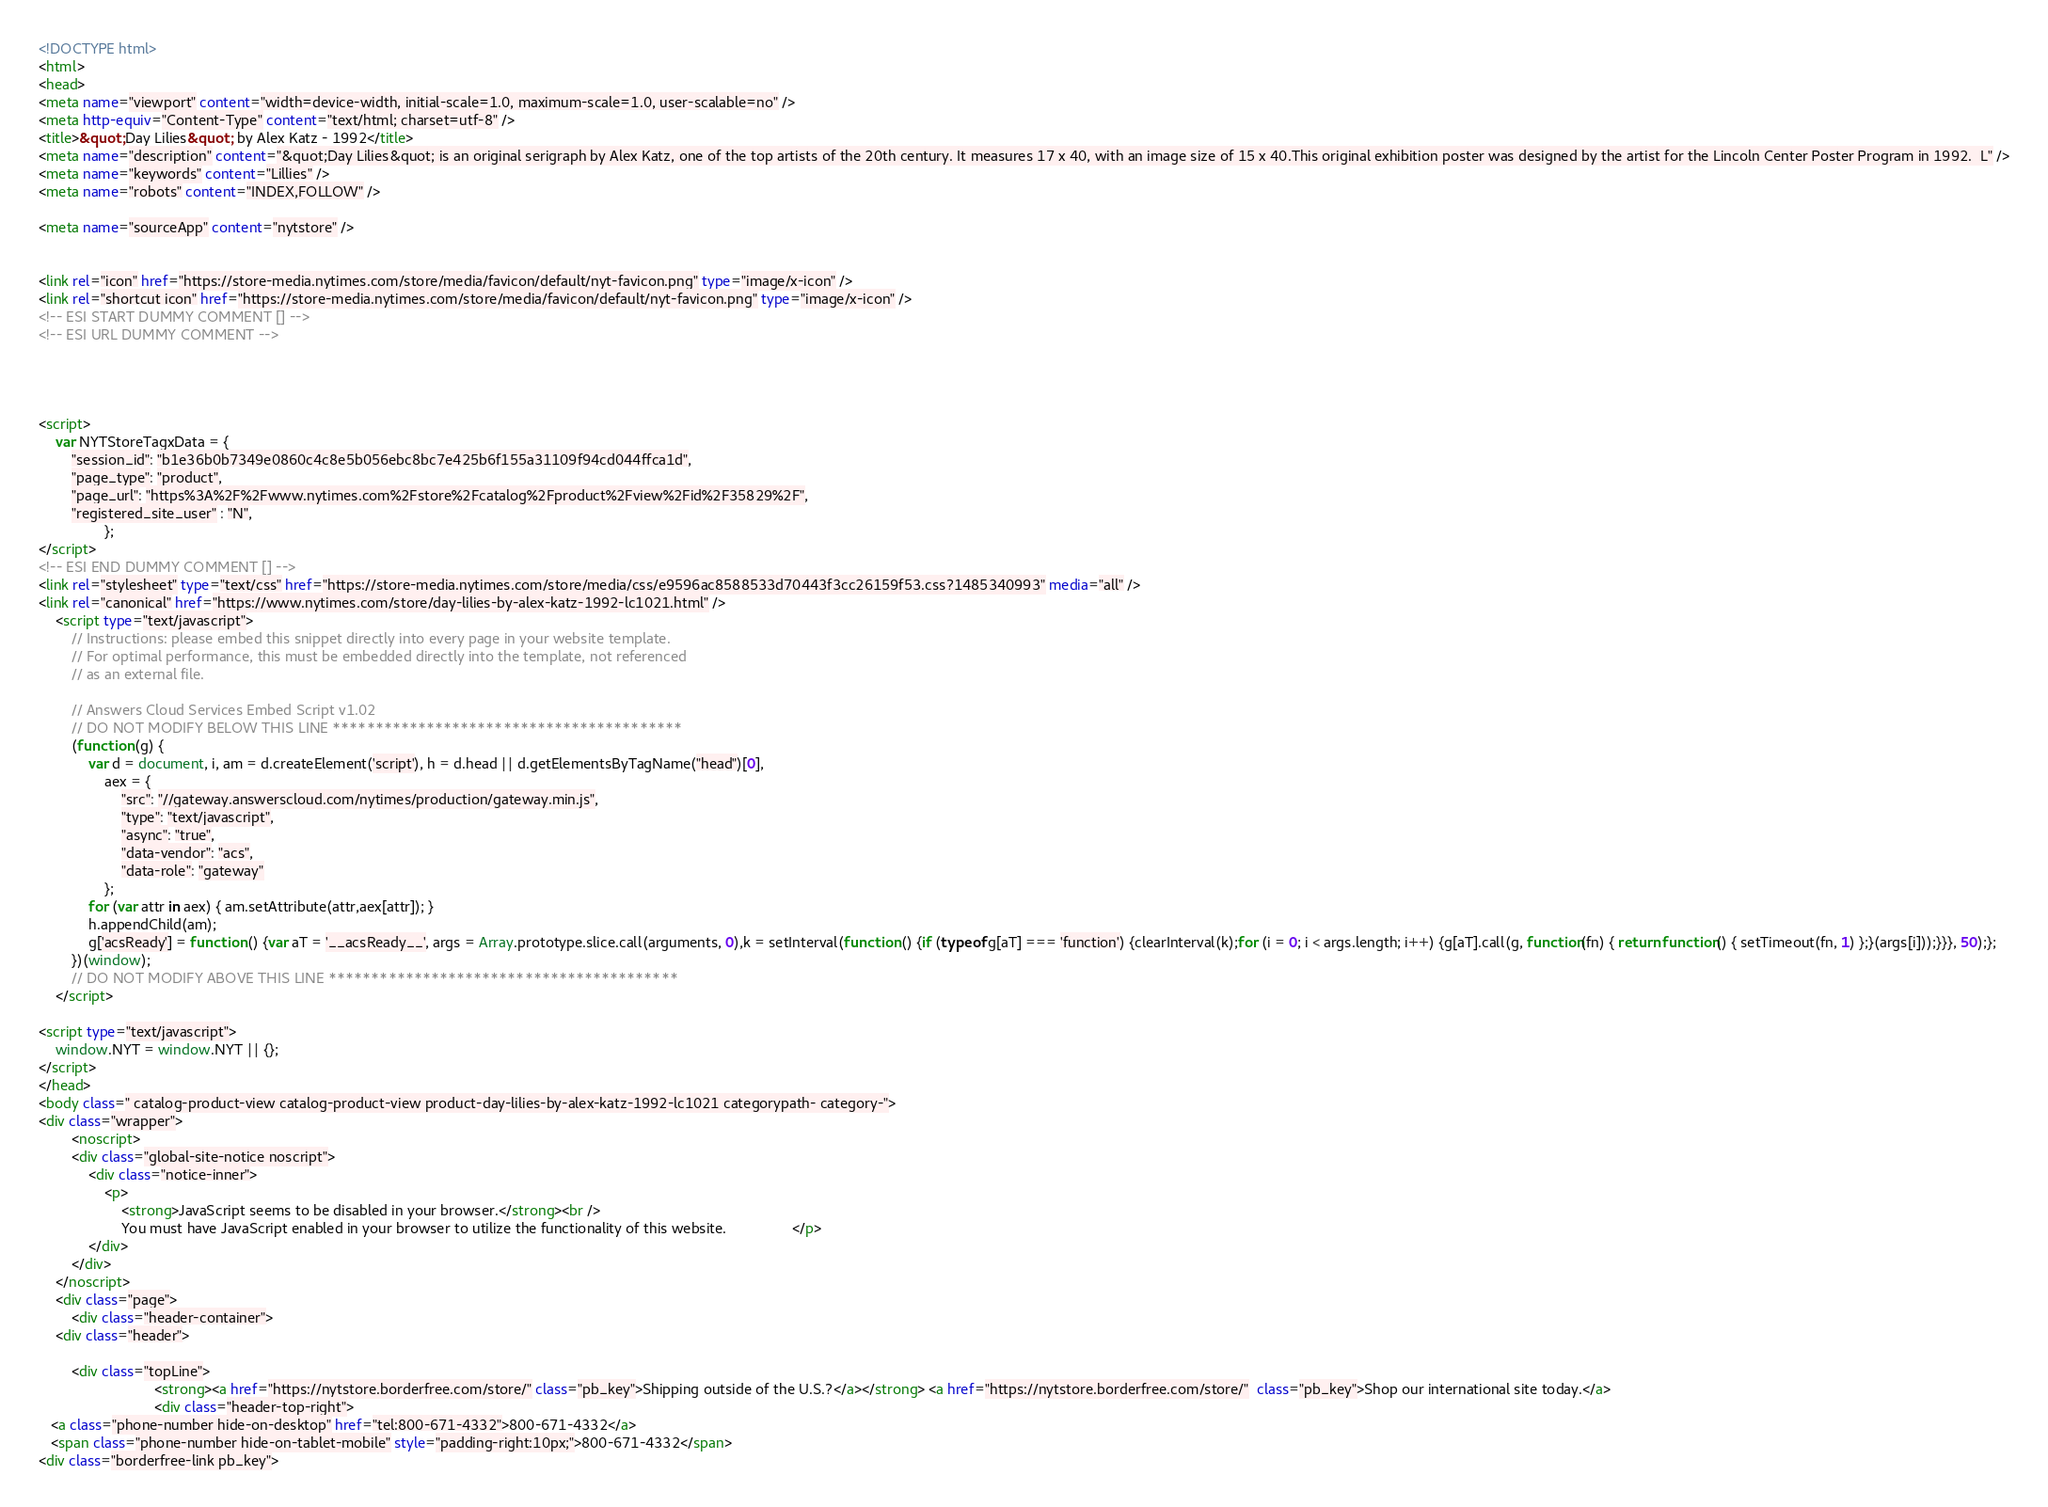<code> <loc_0><loc_0><loc_500><loc_500><_HTML_><!DOCTYPE html>
<html>
<head>
<meta name="viewport" content="width=device-width, initial-scale=1.0, maximum-scale=1.0, user-scalable=no" />
<meta http-equiv="Content-Type" content="text/html; charset=utf-8" />
<title>&quot;Day Lilies&quot; by Alex Katz - 1992</title>
<meta name="description" content="&quot;Day Lilies&quot; is an original serigraph by Alex Katz, one of the top artists of the 20th century. It measures 17 x 40, with an image size of 15 x 40.This original exhibition poster was designed by the artist for the Lincoln Center Poster Program in 1992.  L" />
<meta name="keywords" content="Lillies" />
<meta name="robots" content="INDEX,FOLLOW" />

<meta name="sourceApp" content="nytstore" />


<link rel="icon" href="https://store-media.nytimes.com/store/media/favicon/default/nyt-favicon.png" type="image/x-icon" />
<link rel="shortcut icon" href="https://store-media.nytimes.com/store/media/favicon/default/nyt-favicon.png" type="image/x-icon" />
<!-- ESI START DUMMY COMMENT [] -->
<!-- ESI URL DUMMY COMMENT -->

 


<script>
    var NYTStoreTagxData = {
        "session_id": "b1e36b0b7349e0860c4c8e5b056ebc8bc7e425b6f155a31109f94cd044ffca1d",
        "page_type": "product",
        "page_url": "https%3A%2F%2Fwww.nytimes.com%2Fstore%2Fcatalog%2Fproduct%2Fview%2Fid%2F35829%2F",
        "registered_site_user" : "N",
                };
</script> 
<!-- ESI END DUMMY COMMENT [] -->
<link rel="stylesheet" type="text/css" href="https://store-media.nytimes.com/store/media/css/e9596ac8588533d70443f3cc26159f53.css?1485340993" media="all" />
<link rel="canonical" href="https://www.nytimes.com/store/day-lilies-by-alex-katz-1992-lc1021.html" />
    <script type="text/javascript">
        // Instructions: please embed this snippet directly into every page in your website template.
        // For optimal performance, this must be embedded directly into the template, not referenced
        // as an external file.

        // Answers Cloud Services Embed Script v1.02
        // DO NOT MODIFY BELOW THIS LINE *****************************************
        (function (g) {
            var d = document, i, am = d.createElement('script'), h = d.head || d.getElementsByTagName("head")[0],
                aex = {
                    "src": "//gateway.answerscloud.com/nytimes/production/gateway.min.js",
                    "type": "text/javascript",
                    "async": "true",
                    "data-vendor": "acs",
                    "data-role": "gateway"
                };
            for (var attr in aex) { am.setAttribute(attr,aex[attr]); }
            h.appendChild(am);
            g['acsReady'] = function () {var aT = '__acsReady__', args = Array.prototype.slice.call(arguments, 0),k = setInterval(function () {if (typeof g[aT] === 'function') {clearInterval(k);for (i = 0; i < args.length; i++) {g[aT].call(g, function(fn) { return function() { setTimeout(fn, 1) };}(args[i]));}}}, 50);};
        })(window);
        // DO NOT MODIFY ABOVE THIS LINE *****************************************
    </script>

<script type="text/javascript">
    window.NYT = window.NYT || {};
</script>
</head>
<body class=" catalog-product-view catalog-product-view product-day-lilies-by-alex-katz-1992-lc1021 categorypath- category-">
<div class="wrapper">
        <noscript>
        <div class="global-site-notice noscript">
            <div class="notice-inner">
                <p>
                    <strong>JavaScript seems to be disabled in your browser.</strong><br />
                    You must have JavaScript enabled in your browser to utilize the functionality of this website.                </p>
            </div>
        </div>
    </noscript>
    <div class="page">
        <div class="header-container">
    <div class="header">

        <div class="topLine">
                            <strong><a href="https://nytstore.borderfree.com/store/" class="pb_key">Shipping outside of the U.S.?</a></strong> <a href="https://nytstore.borderfree.com/store/"  class="pb_key">Shop our international site today.</a>             
                            <div class="header-top-right">
   <a class="phone-number hide-on-desktop" href="tel:800-671-4332">800-671-4332</a>
   <span class="phone-number hide-on-tablet-mobile" style="padding-right:10px;">800-671-4332</span>
<div class="borderfree-link pb_key"></code> 